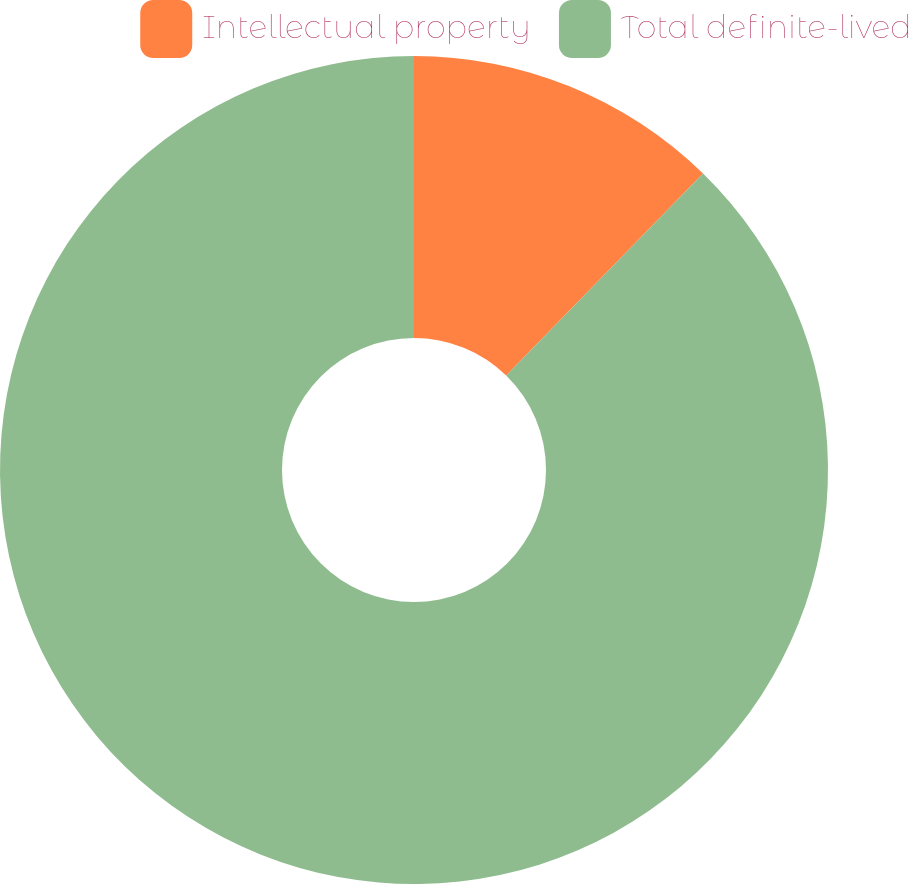Convert chart. <chart><loc_0><loc_0><loc_500><loc_500><pie_chart><fcel>Intellectual property<fcel>Total definite-lived<nl><fcel>12.3%<fcel>87.7%<nl></chart> 